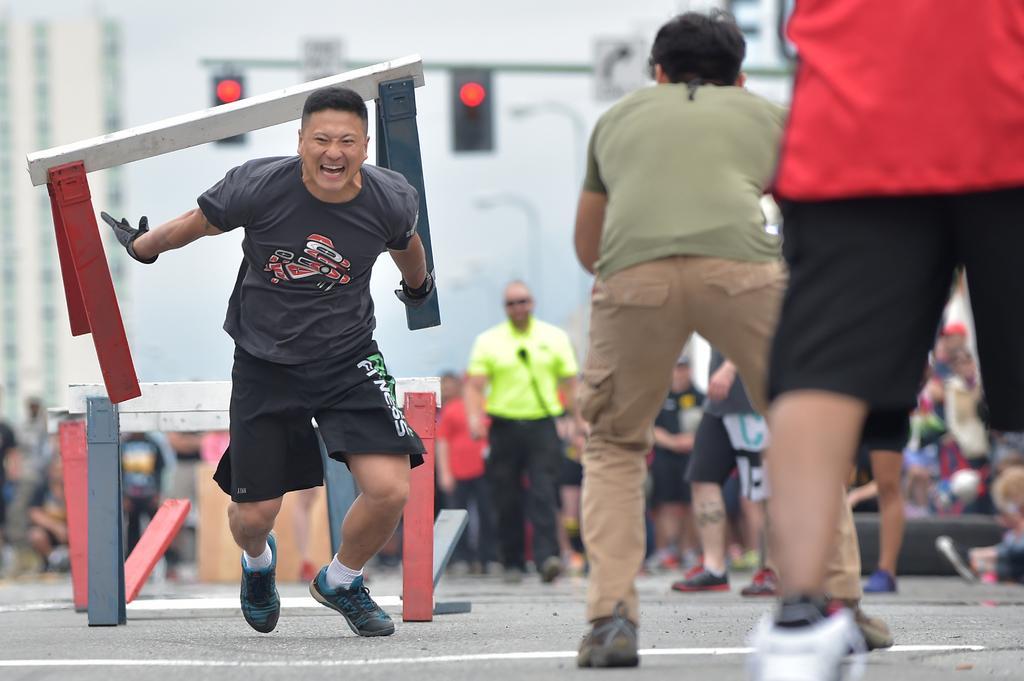Describe this image in one or two sentences. In this picture I can see a man running, there are hurdles, there are signal lights to a pole, there are group of people, and there is blur background. 